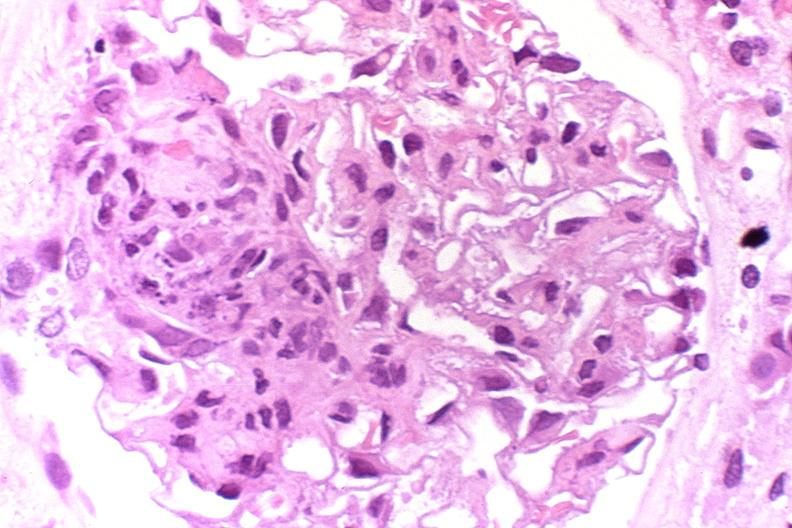where is this?
Answer the question using a single word or phrase. Urinary 